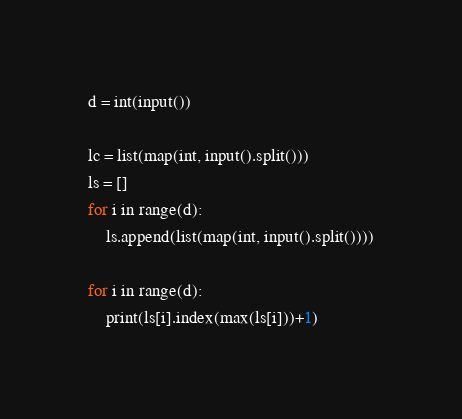<code> <loc_0><loc_0><loc_500><loc_500><_Python_>d = int(input())

lc = list(map(int, input().split()))
ls = []
for i in range(d):
    ls.append(list(map(int, input().split())))

for i in range(d):
    print(ls[i].index(max(ls[i]))+1)
</code> 